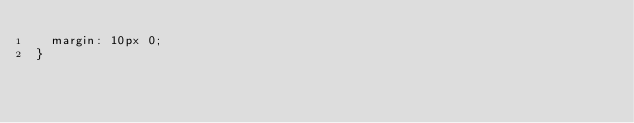Convert code to text. <code><loc_0><loc_0><loc_500><loc_500><_CSS_>  margin: 10px 0;
}
</code> 